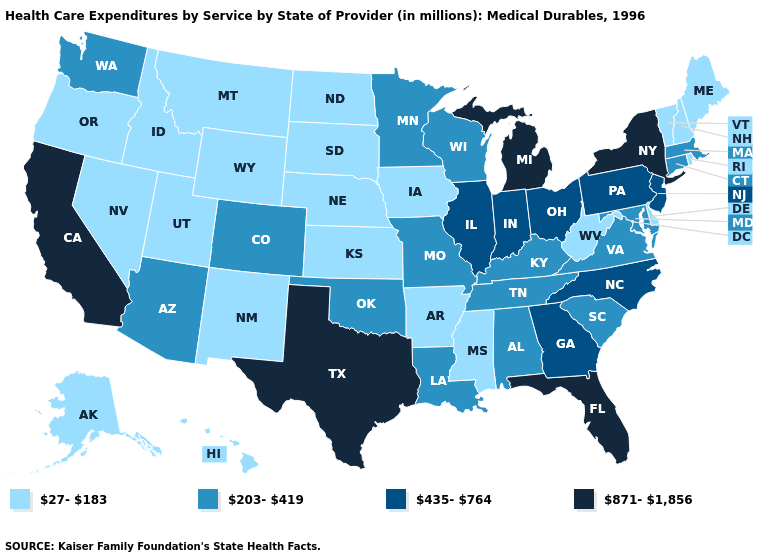Does the first symbol in the legend represent the smallest category?
Quick response, please. Yes. How many symbols are there in the legend?
Answer briefly. 4. Is the legend a continuous bar?
Keep it brief. No. What is the lowest value in the USA?
Answer briefly. 27-183. Does North Dakota have the lowest value in the USA?
Be succinct. Yes. Name the states that have a value in the range 871-1,856?
Quick response, please. California, Florida, Michigan, New York, Texas. Name the states that have a value in the range 435-764?
Answer briefly. Georgia, Illinois, Indiana, New Jersey, North Carolina, Ohio, Pennsylvania. Does New York have the highest value in the Northeast?
Answer briefly. Yes. Which states have the lowest value in the USA?
Write a very short answer. Alaska, Arkansas, Delaware, Hawaii, Idaho, Iowa, Kansas, Maine, Mississippi, Montana, Nebraska, Nevada, New Hampshire, New Mexico, North Dakota, Oregon, Rhode Island, South Dakota, Utah, Vermont, West Virginia, Wyoming. What is the highest value in states that border Montana?
Short answer required. 27-183. Is the legend a continuous bar?
Give a very brief answer. No. Among the states that border New Mexico , which have the highest value?
Be succinct. Texas. What is the highest value in the USA?
Concise answer only. 871-1,856. Among the states that border Arizona , does Colorado have the lowest value?
Keep it brief. No. Among the states that border Louisiana , does Texas have the lowest value?
Answer briefly. No. 